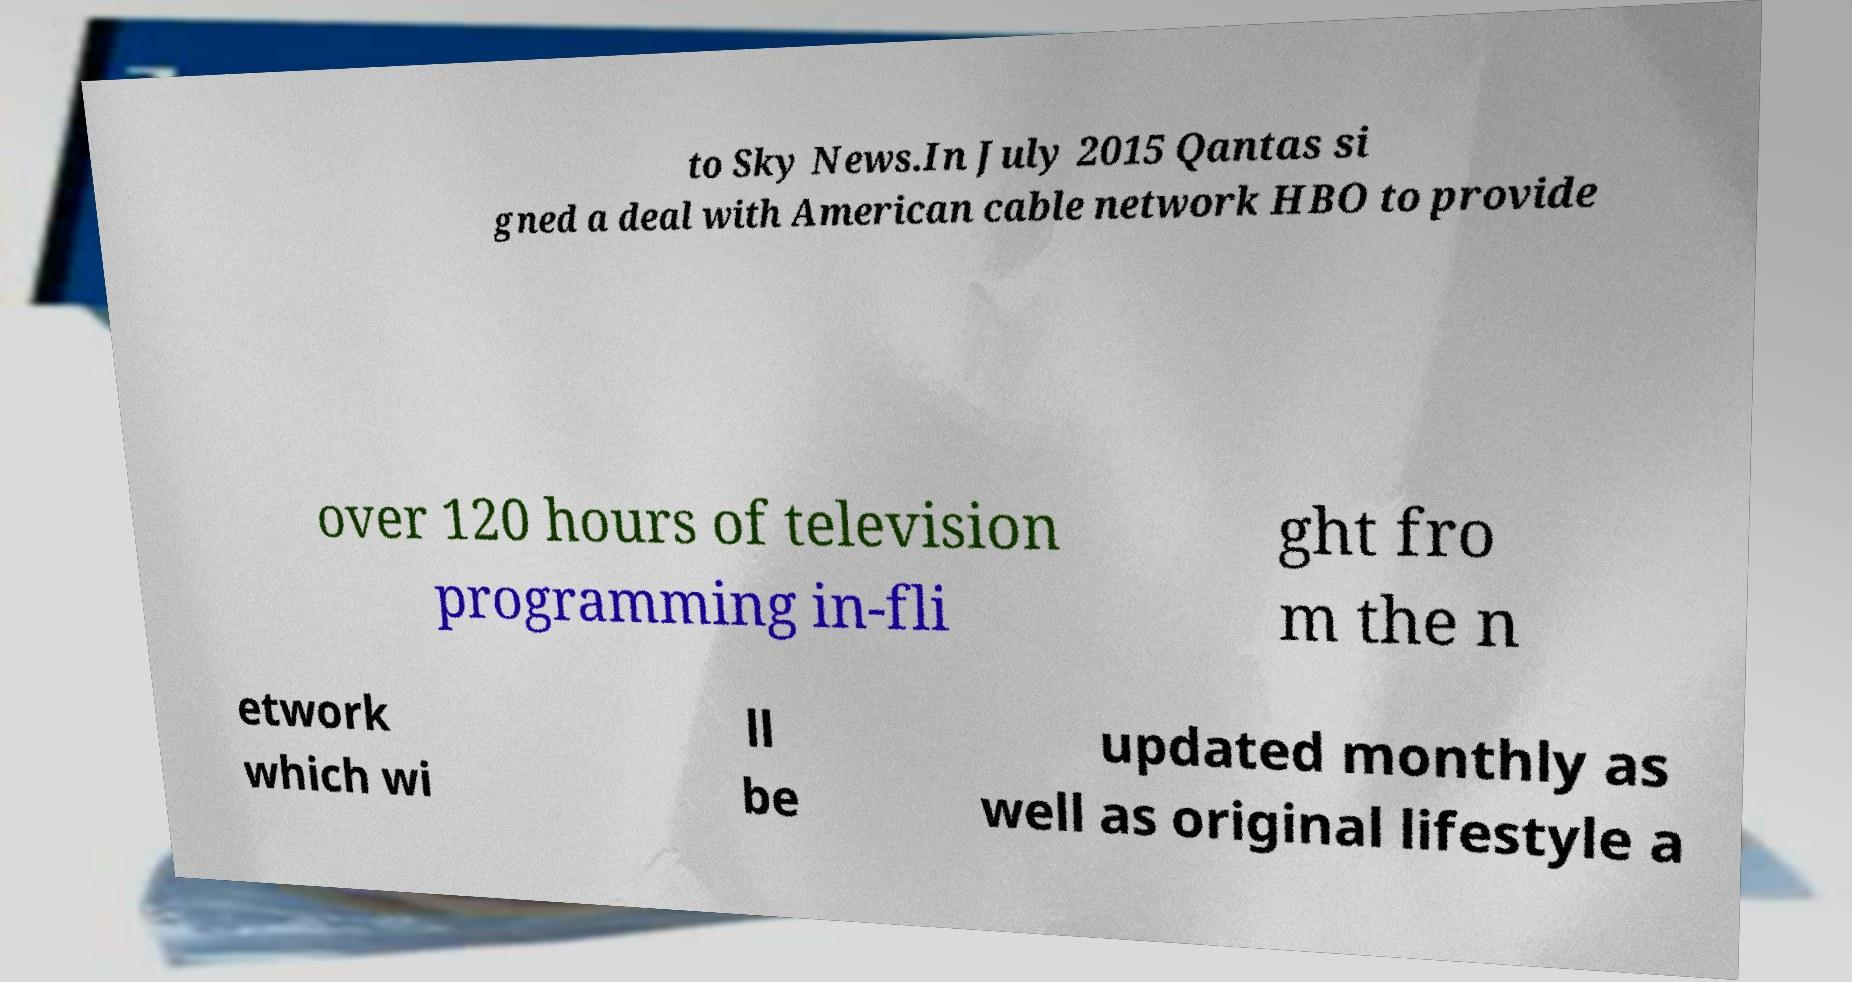Can you accurately transcribe the text from the provided image for me? to Sky News.In July 2015 Qantas si gned a deal with American cable network HBO to provide over 120 hours of television programming in-fli ght fro m the n etwork which wi ll be updated monthly as well as original lifestyle a 